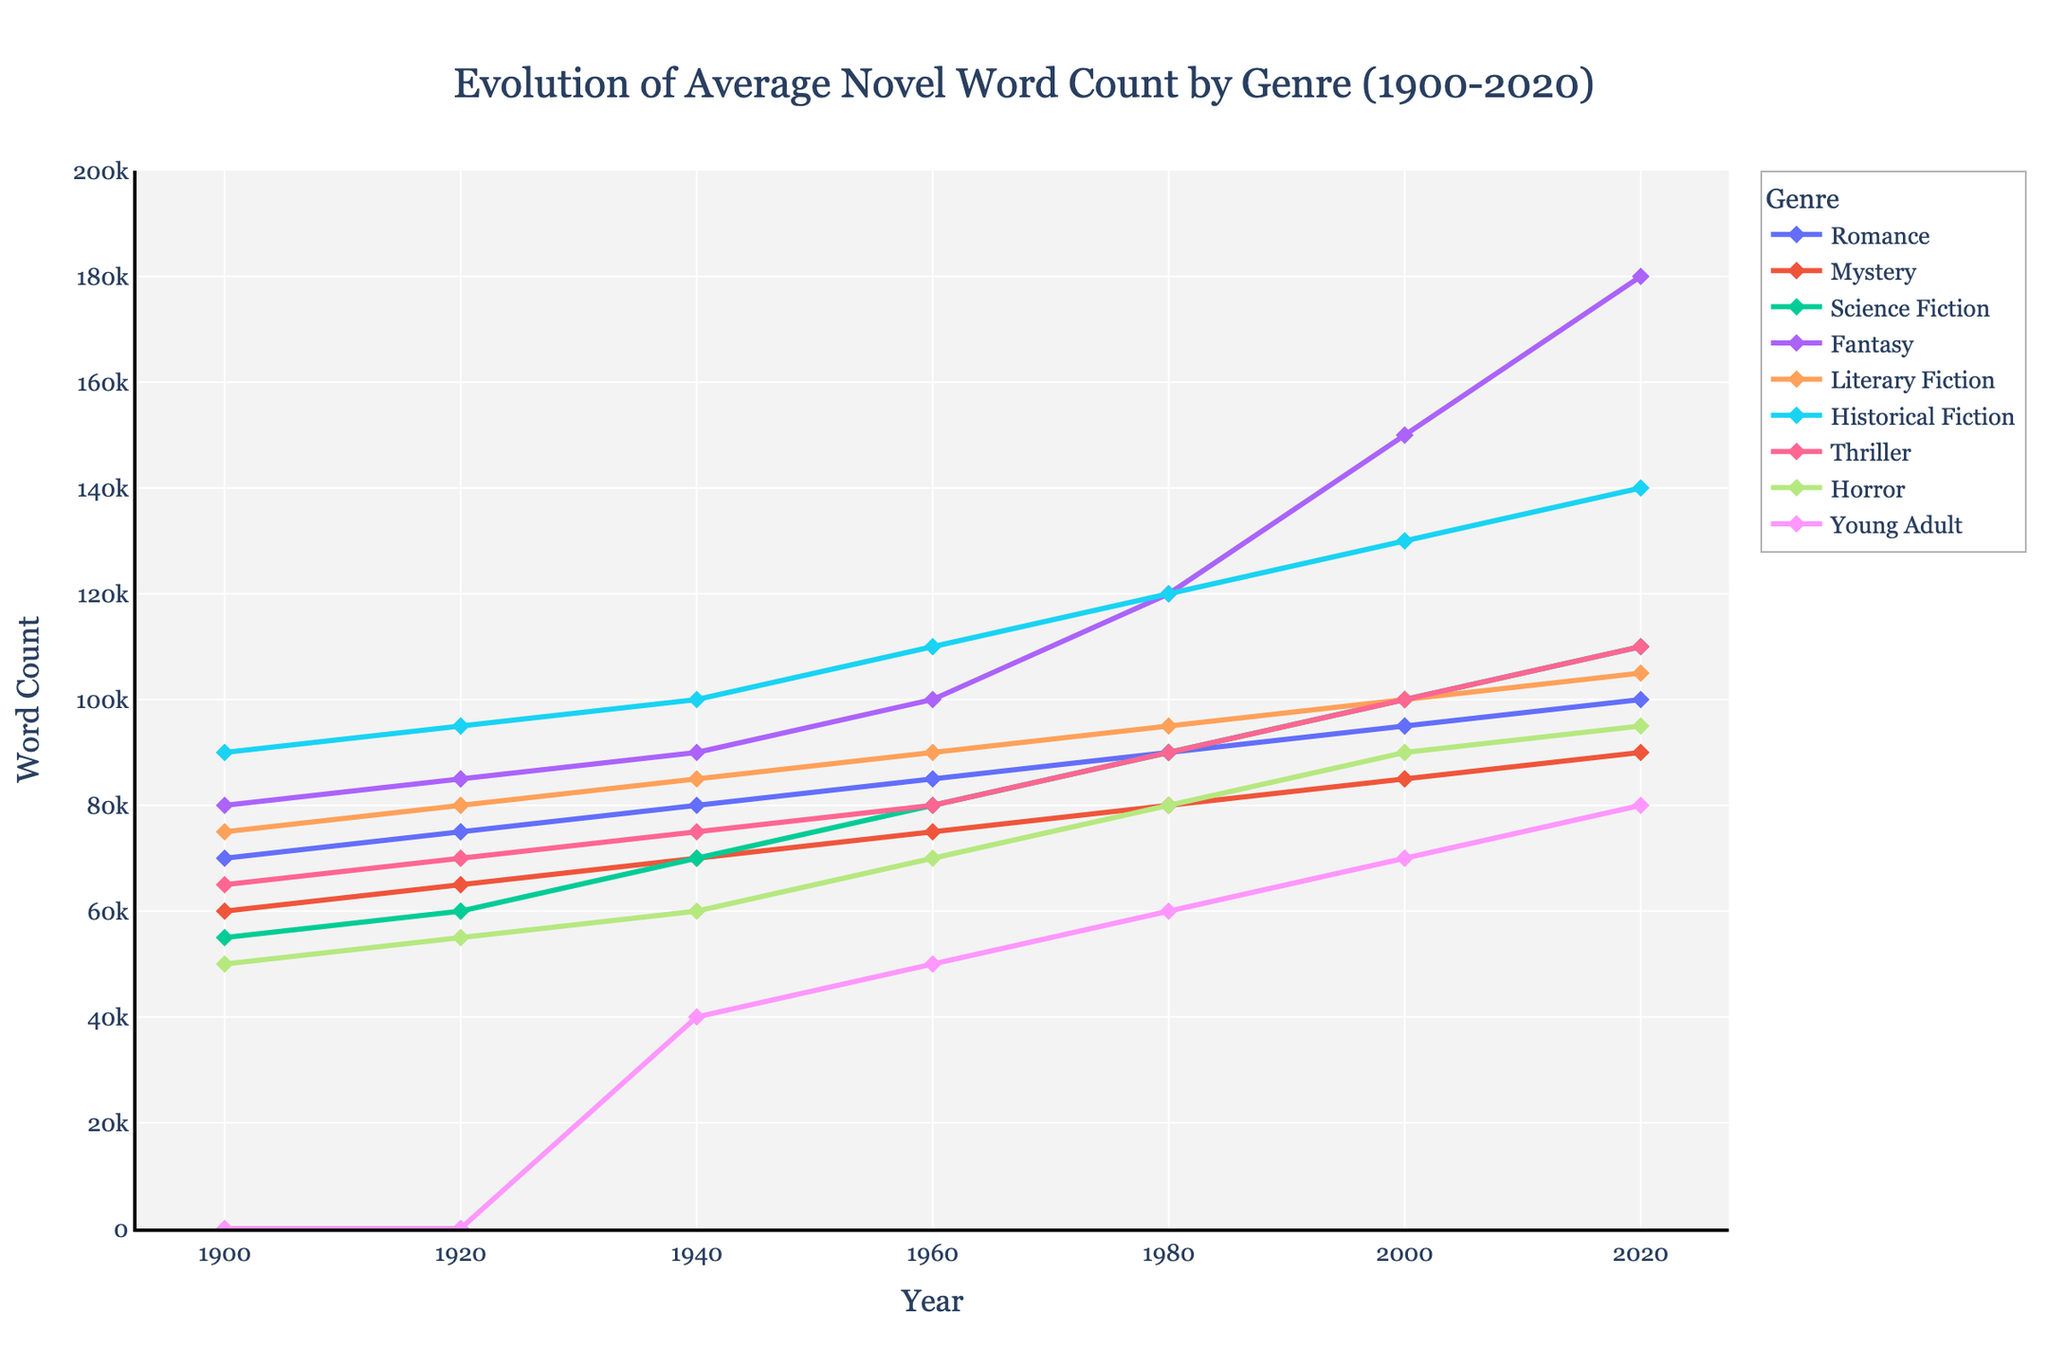What genre experienced the largest increase in average word count from 1900 to 2020? To determine which genre experienced the largest increase in average word count, we subtract the 1900 word count from the 2020 word count for each genre. Romance increased from 70,000 to 100,000 (30,000), Mystery from 60,000 to 90,000 (30,000), Science Fiction from 55,000 to 110,000 (55,000), Fantasy from 80,000 to 180,000 (100,000), Literary Fiction from 75,000 to 105,000 (30,000), Historical Fiction from 90,000 to 140,000 (50,000), Thriller from 65,000 to 110,000 (45,000), Horror from 50,000 to 95,000 (45,000), and Young Adult from 0 to 80,000 (80,000). Fantasy saw the largest increase of 100,000 words.
Answer: Fantasy What genre had the highest average word count in 1980? To find this, we look at the data for each genre for the year 1980. Romance had 90,000 words, Mystery 80,000, Science Fiction 90,000, Fantasy 120,000, Literary Fiction 95,000, Historical Fiction 120,000, Thriller 90,000, Horror 80,000, and Young Adult 60,000. Both Fantasy and Historical Fiction had the highest average word count at 120,000.
Answer: Fantasy and Historical Fiction Between 1940 and 2020, which genre had the smallest increase in word count? Calculate the increase in word count from 1940 to 2020 for each genre: Romance increased from 80,000 to 100,000 (20,000), Mystery from 70,000 to 90,000 (20,000), Science Fiction from 70,000 to 110,000 (40,000), Fantasy from 90,000 to 180,000 (90,000), Literary Fiction from 85,000 to 105,000 (20,000), Historical Fiction from 100,000 to 140,000 (40,000), Thriller from 75,000 to 110,000 (35,000), Horror from 60,000 to 95,000 (35,000), and Young Adult from 40,000 to 80,000 (40,000). Romance, Mystery, and Literary Fiction all had the smallest increase of 20,000 words.
Answer: Romance, Mystery, and Literary Fiction Which genre had the slowest average word count growth rate from 1900 to 2020? To find the slowest rate of growth, we calculate the increase per year (change in word count divided by the number of years, 120). For Romance, it's (100,000 - 70,000)/120 = 250 words/year. Mystery: (90,000 - 60,000)/120 = 250 words/year. Science Fiction: (110,000 - 55,000)/120 ≈ 458 words/year. Fantasy: (180,000 - 80,000)/120 ≈ 833 words/year. Literary Fiction: (105,000 - 75,000)/120 ≈ 250 words/year. Historical Fiction: (140,000 - 90,000)/120 ≈ 417 words/year. Thriller: (110,000 - 65,000)/120 ≈ 375 words/year. Horror: (95,000 - 50,000)/120 ≈ 375 words/year. Young Adult is excluded as it starts at 1940. The slowest growth rate is shared by Romance, Mystery, and Literary Fiction at approximately 250 words/year.
Answer: Romance, Mystery, and Literary Fiction Examine the trends from 2000 to 2020. Which genre saw the most dramatic increase in this period? We calculate the increase for each genre between 2000 and 2020: Romance from 95,000 to 100,000 (5,000), Mystery from 85,000 to 90,000 (5,000), Science Fiction from 100,000 to 110,000 (10,000), Fantasy from 150,000 to 180,000 (30,000), Literary Fiction from 100,000 to 105,000 (5,000), Historical Fiction from 130,000 to 140,000 (10,000), Thriller from 100,000 to 110,000 (10,000), Horror from 90,000 to 95,000 (5,000), and Young Adult from 70,000 to 80,000 (10,000). Fantasy saw the most dramatic increase of 30,000 words.
Answer: Fantasy Among the genres listed, which had the lowest average word count in 2020? By examining the 2020 word count values for all genres, we find: Romance 100,000, Mystery 90,000, Science Fiction 110,000, Fantasy 180,000, Literary Fiction 105,000, Historical Fiction 140,000, Thriller 110,000, Horror 95,000, and Young Adult 80,000. The genre with the lowest average word count in 2020 is Young Adult at 80,000 words.
Answer: Young Adult Which two genres showed equal growth in average word count from 1940 to 1980? Calculate the increase in word count from 1940 to 1980 for each genre: Romance increased from 80,000 to 90,000 (10,000), Mystery from 70,000 to 80,000 (10,000), Science Fiction from 70,000 to 90,000 (20,000), Fantasy from 90,000 to 120,000 (30,000), Literary Fiction from 85,000 to 95,000 (10,000), Historical Fiction from 100,000 to 120,000 (20,000), Thriller from 75,000 to 90,000 (15,000), Horror from 60,000 to 80,000 (20,000), and Young Adult from 40,000 to 60,000 (20,000). Romance, Mystery, and Literary Fiction all grew by 10,000 words.
Answer: Romance, Mystery, and Literary Fiction 